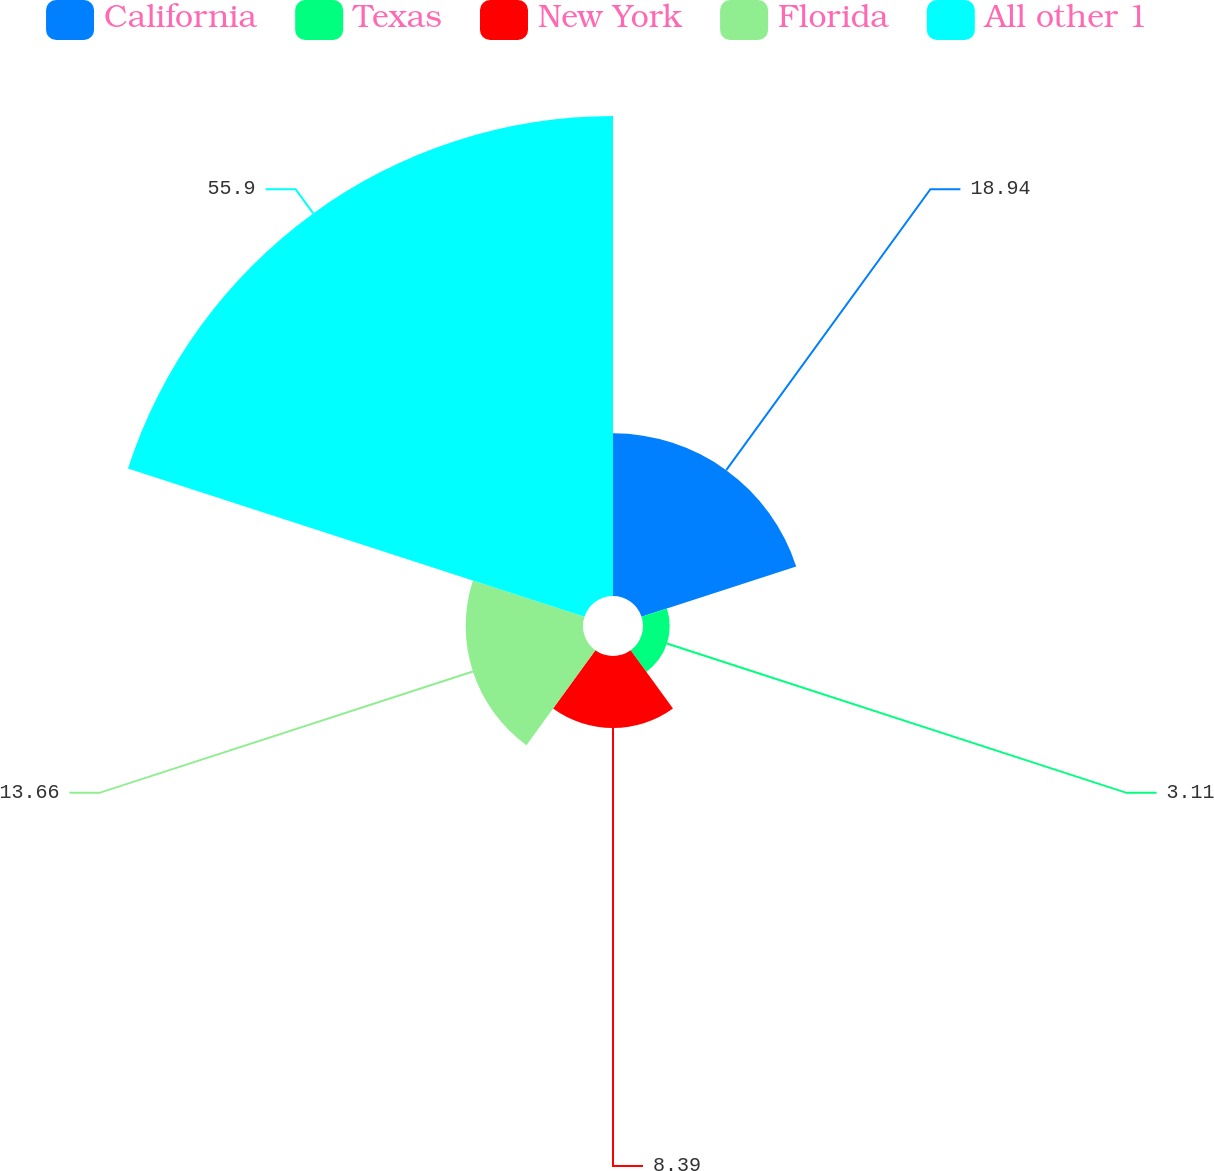Convert chart to OTSL. <chart><loc_0><loc_0><loc_500><loc_500><pie_chart><fcel>California<fcel>Texas<fcel>New York<fcel>Florida<fcel>All other 1<nl><fcel>18.94%<fcel>3.11%<fcel>8.39%<fcel>13.66%<fcel>55.9%<nl></chart> 